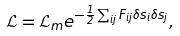Convert formula to latex. <formula><loc_0><loc_0><loc_500><loc_500>\mathcal { L } = \mathcal { L } _ { m } e ^ { - { \frac { 1 } { 2 } } \sum _ { i j } F _ { i j } \delta s _ { i } \delta s _ { j } } ,</formula> 